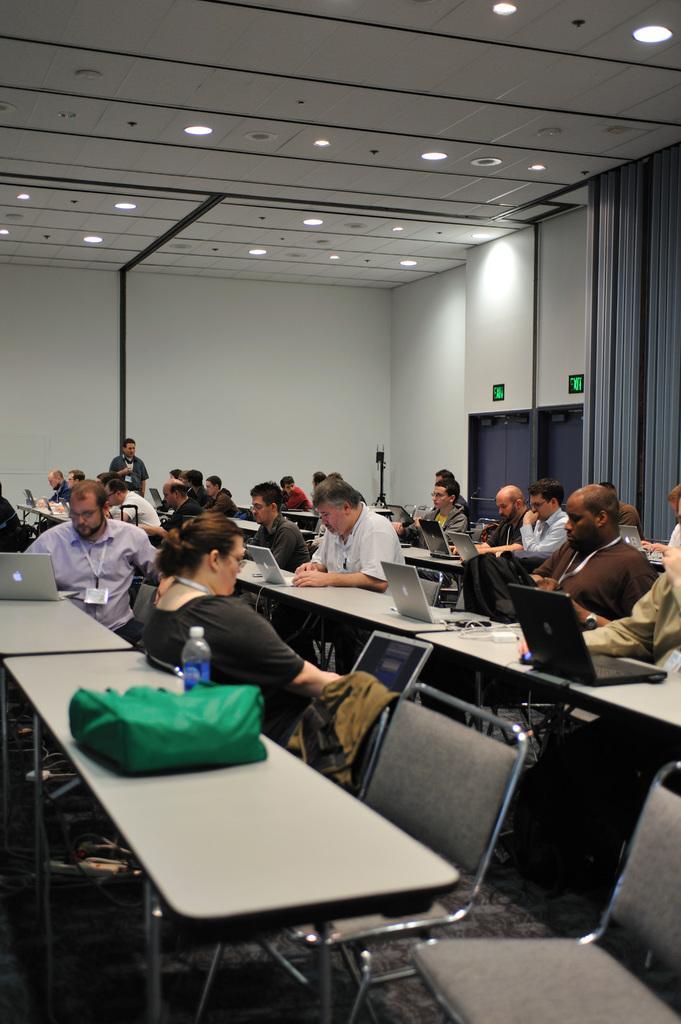Could you give a brief overview of what you see in this image? At the top we can see ceiling and lights. This is a wall and door. Here we can see curtains. In the picture we can see all the persons sitting on chairs in front of a table and on the table we can see laptops, bag, bottles. This is a floor. We can see one man standing here near to the wall. 